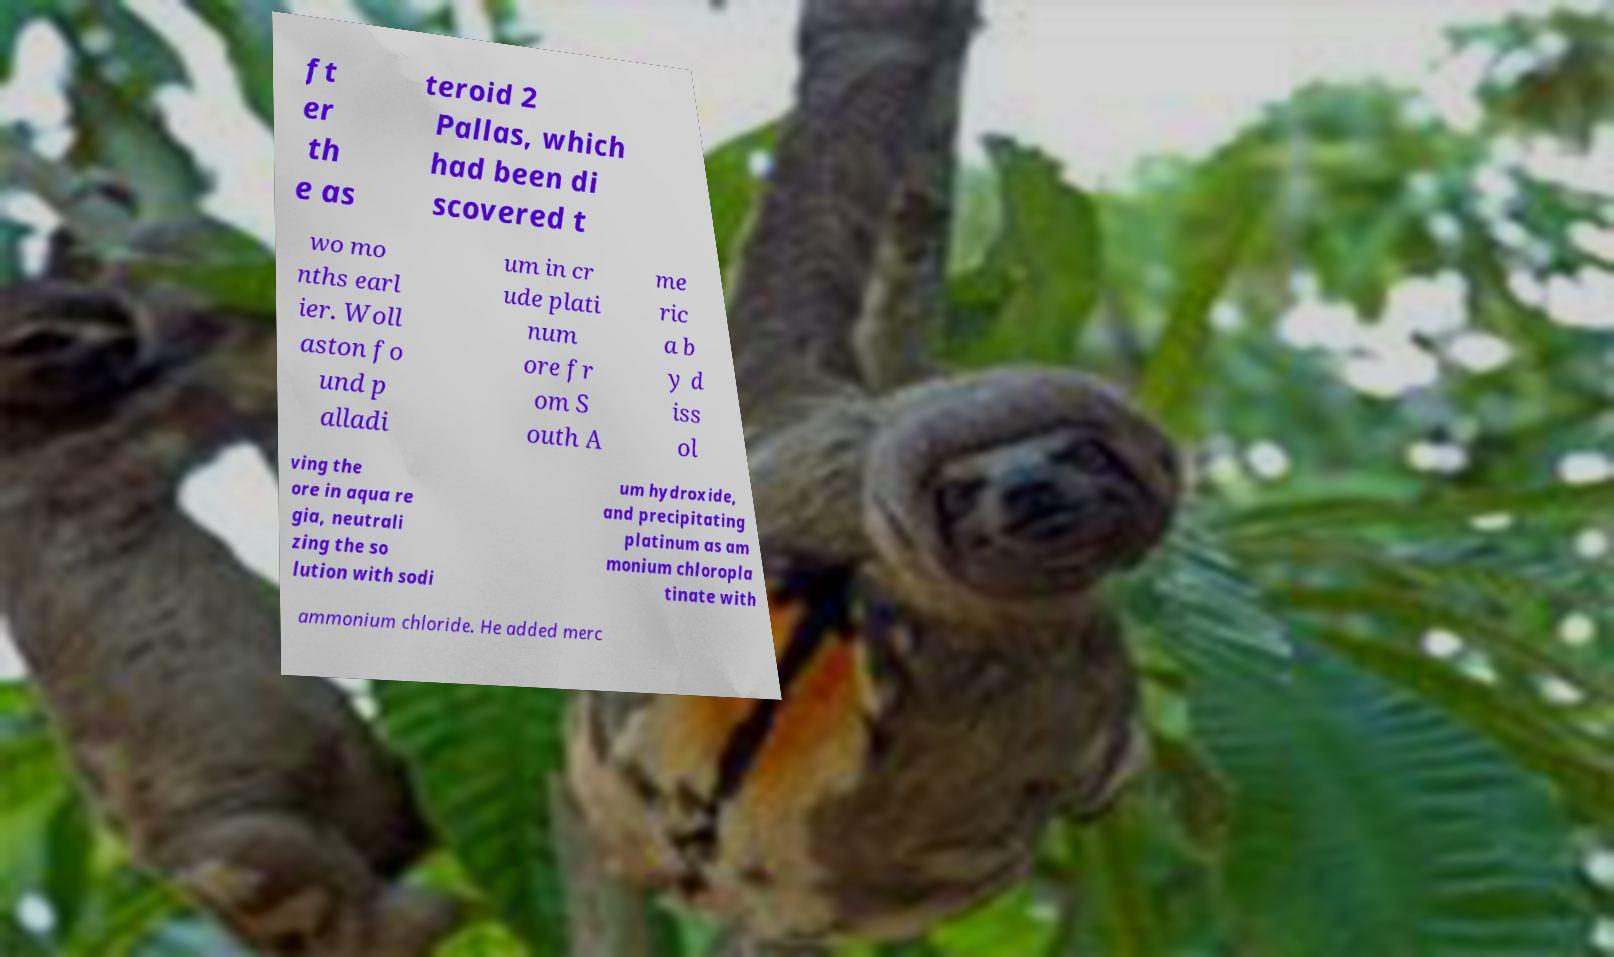Please read and relay the text visible in this image. What does it say? ft er th e as teroid 2 Pallas, which had been di scovered t wo mo nths earl ier. Woll aston fo und p alladi um in cr ude plati num ore fr om S outh A me ric a b y d iss ol ving the ore in aqua re gia, neutrali zing the so lution with sodi um hydroxide, and precipitating platinum as am monium chloropla tinate with ammonium chloride. He added merc 